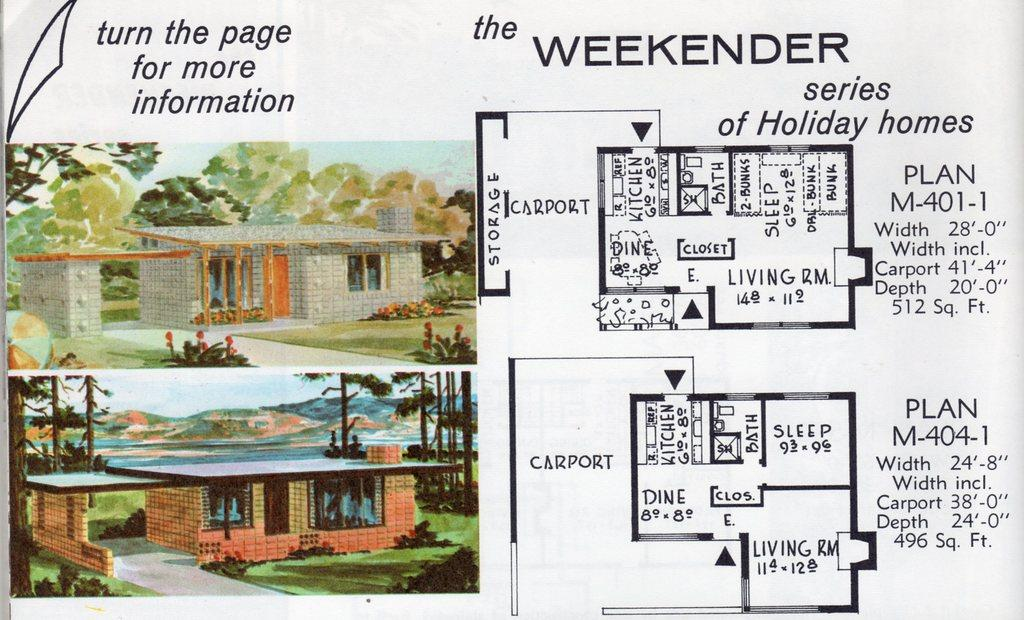<image>
Share a concise interpretation of the image provided. An illustration details floor plans for a housing development called the Weekender. 